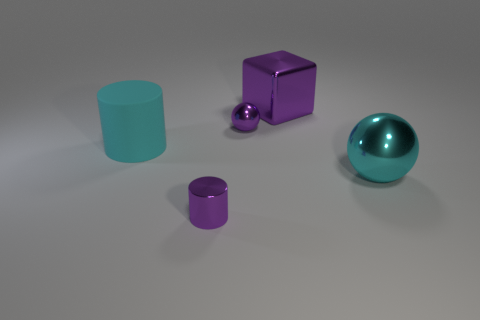Add 4 small gray spheres. How many objects exist? 9 Subtract all blocks. How many objects are left? 4 Add 4 balls. How many balls are left? 6 Add 4 blue balls. How many blue balls exist? 4 Subtract 0 yellow blocks. How many objects are left? 5 Subtract all metallic objects. Subtract all rubber cylinders. How many objects are left? 0 